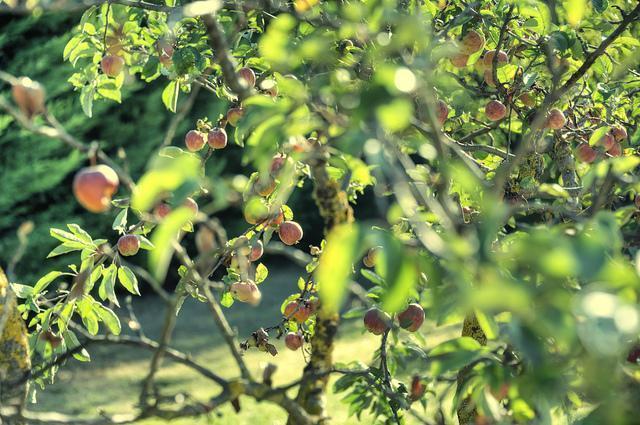How many bananas are hanging from the tree?
Give a very brief answer. 0. How many birds are depicted?
Give a very brief answer. 0. How many people are in the chair lift?
Give a very brief answer. 0. 